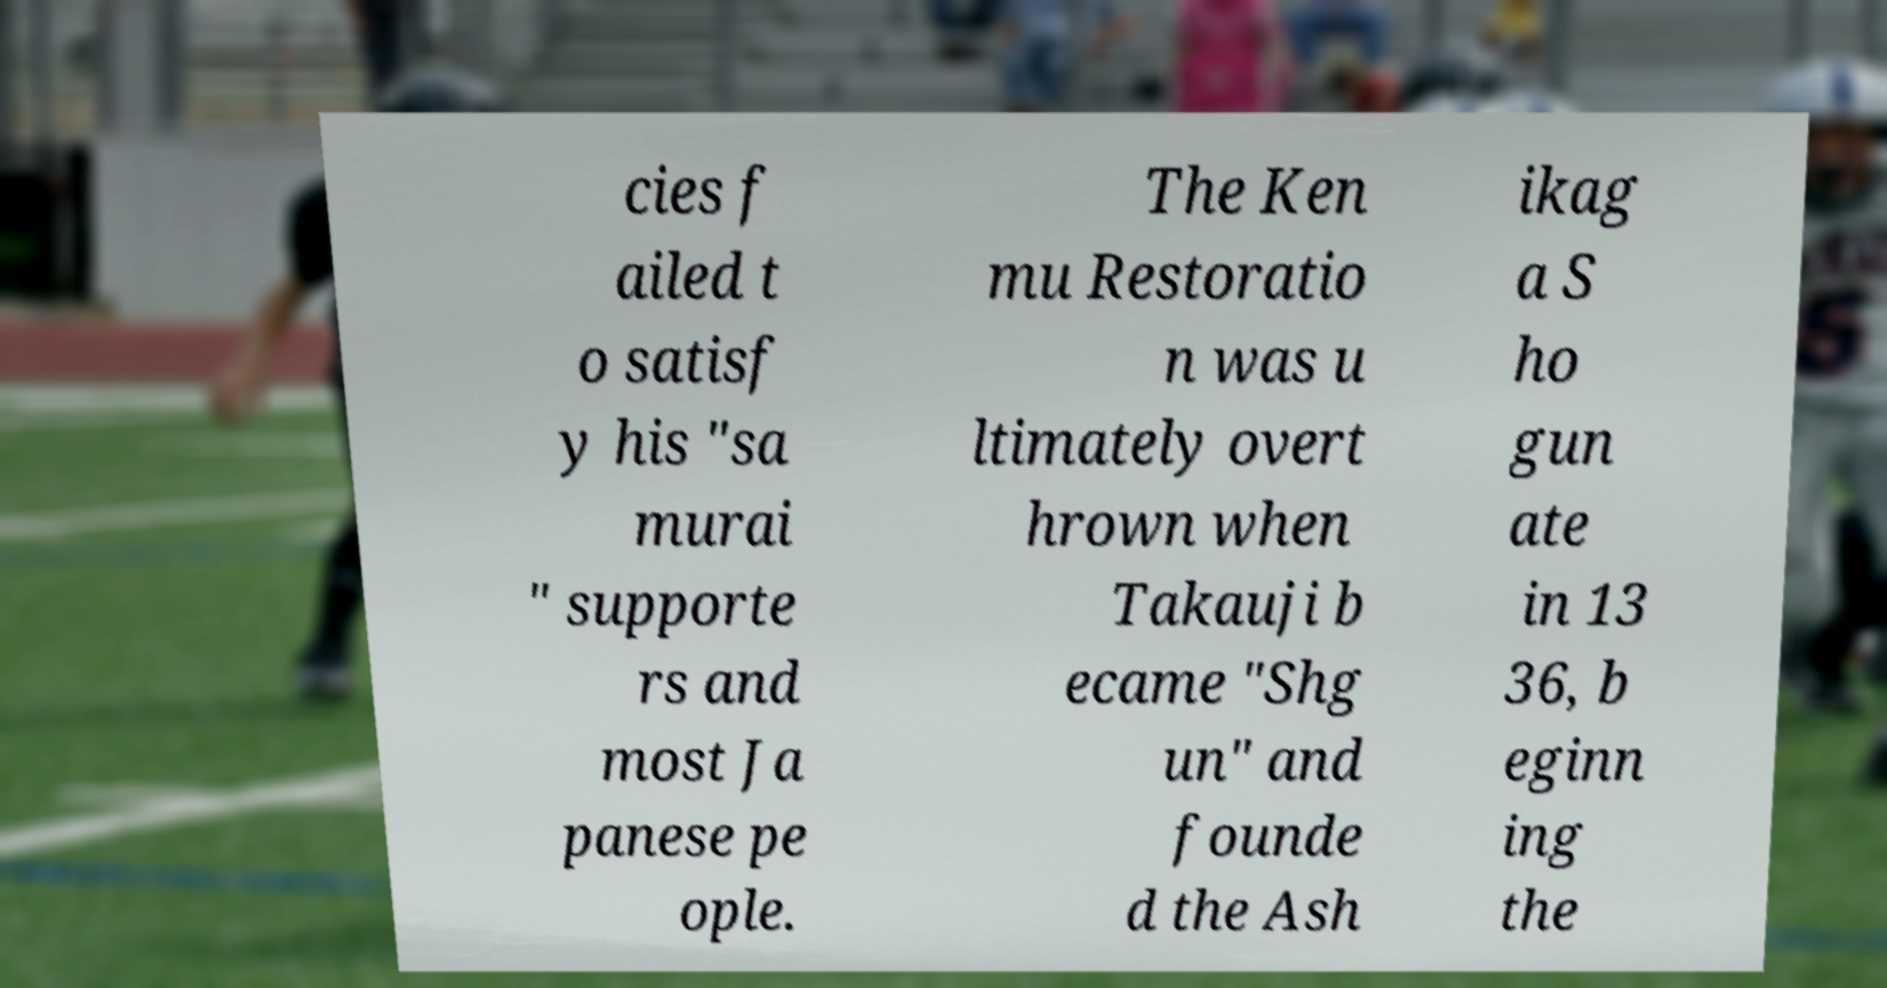What messages or text are displayed in this image? I need them in a readable, typed format. cies f ailed t o satisf y his "sa murai " supporte rs and most Ja panese pe ople. The Ken mu Restoratio n was u ltimately overt hrown when Takauji b ecame "Shg un" and founde d the Ash ikag a S ho gun ate in 13 36, b eginn ing the 